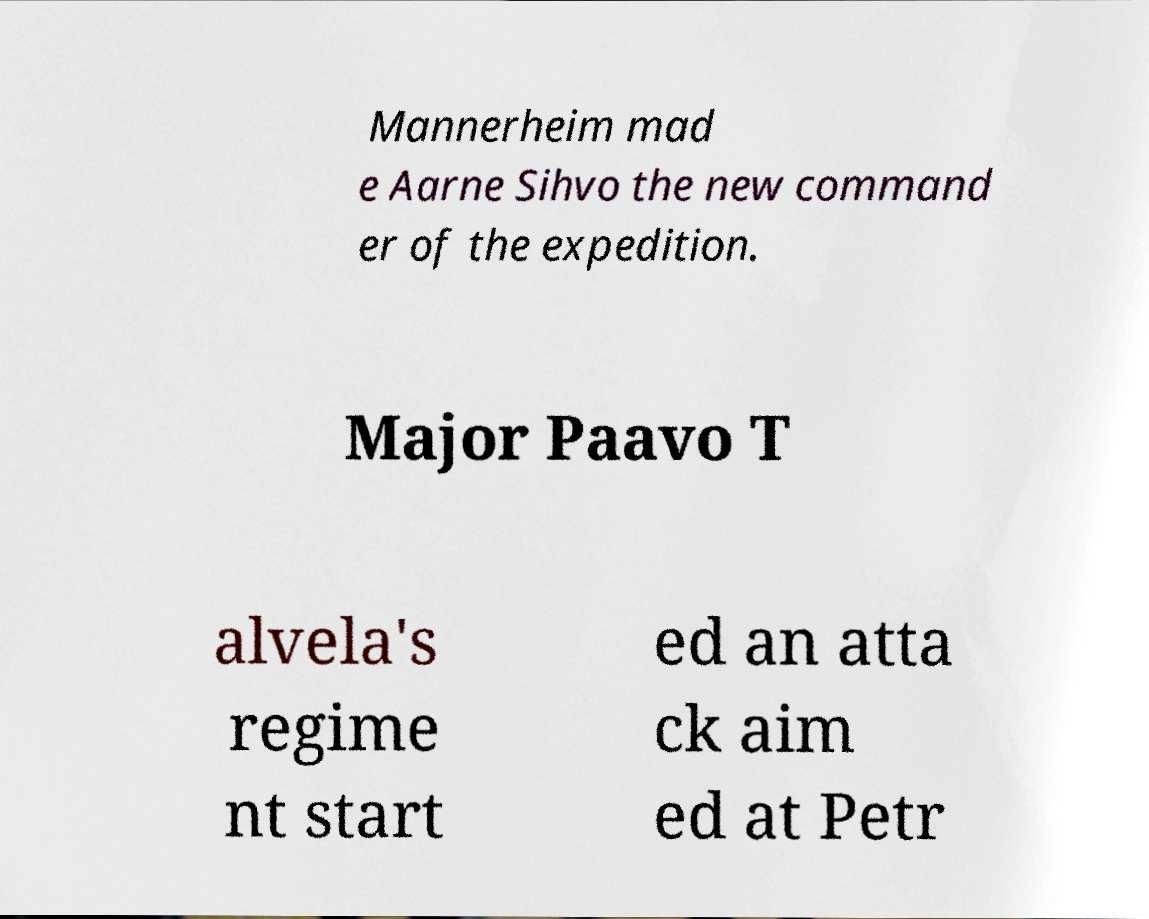There's text embedded in this image that I need extracted. Can you transcribe it verbatim? Mannerheim mad e Aarne Sihvo the new command er of the expedition. Major Paavo T alvela's regime nt start ed an atta ck aim ed at Petr 